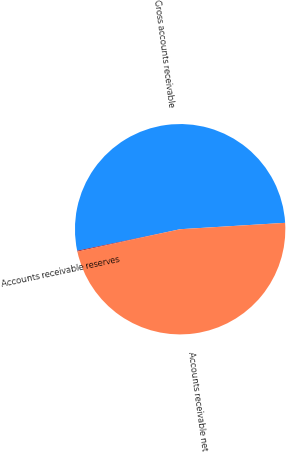Convert chart. <chart><loc_0><loc_0><loc_500><loc_500><pie_chart><fcel>Gross accounts receivable<fcel>Accounts receivable reserves<fcel>Accounts receivable net<nl><fcel>52.32%<fcel>0.12%<fcel>47.56%<nl></chart> 